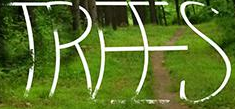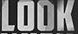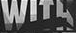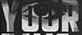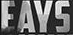Transcribe the words shown in these images in order, separated by a semicolon. TREES; LOOK; WITH; YOUR; EAYS 